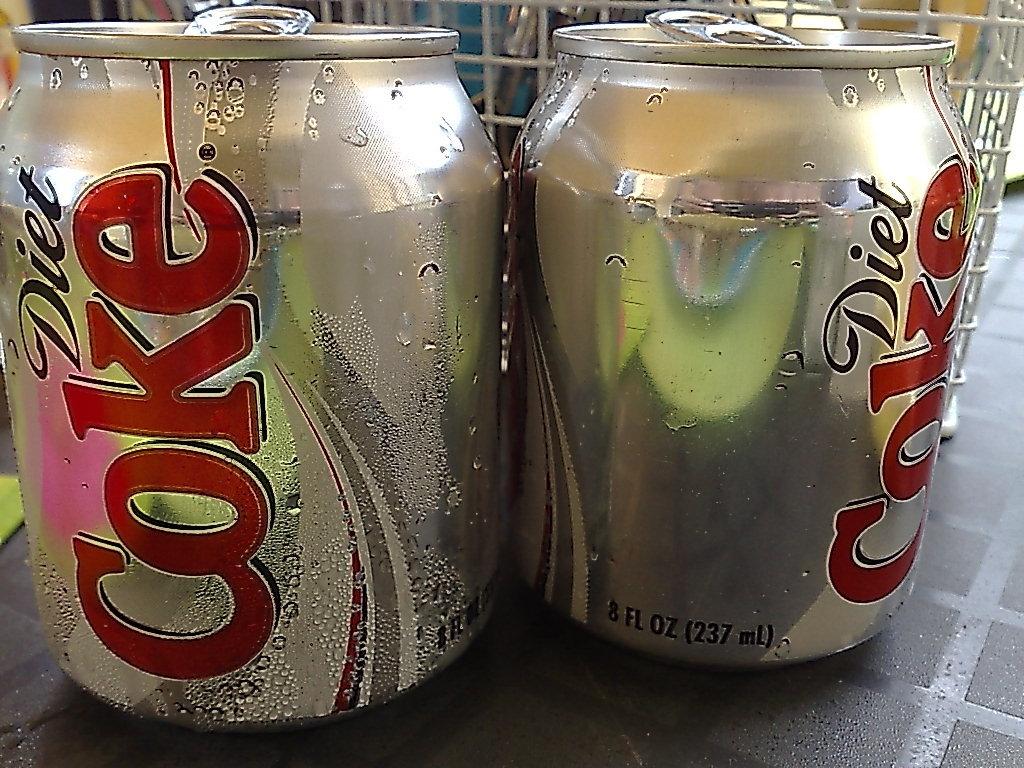Is this diet coke or regular coke?
Provide a succinct answer. Diet. How much diet coke are in these cans?
Offer a very short reply. 8 fl oz. 